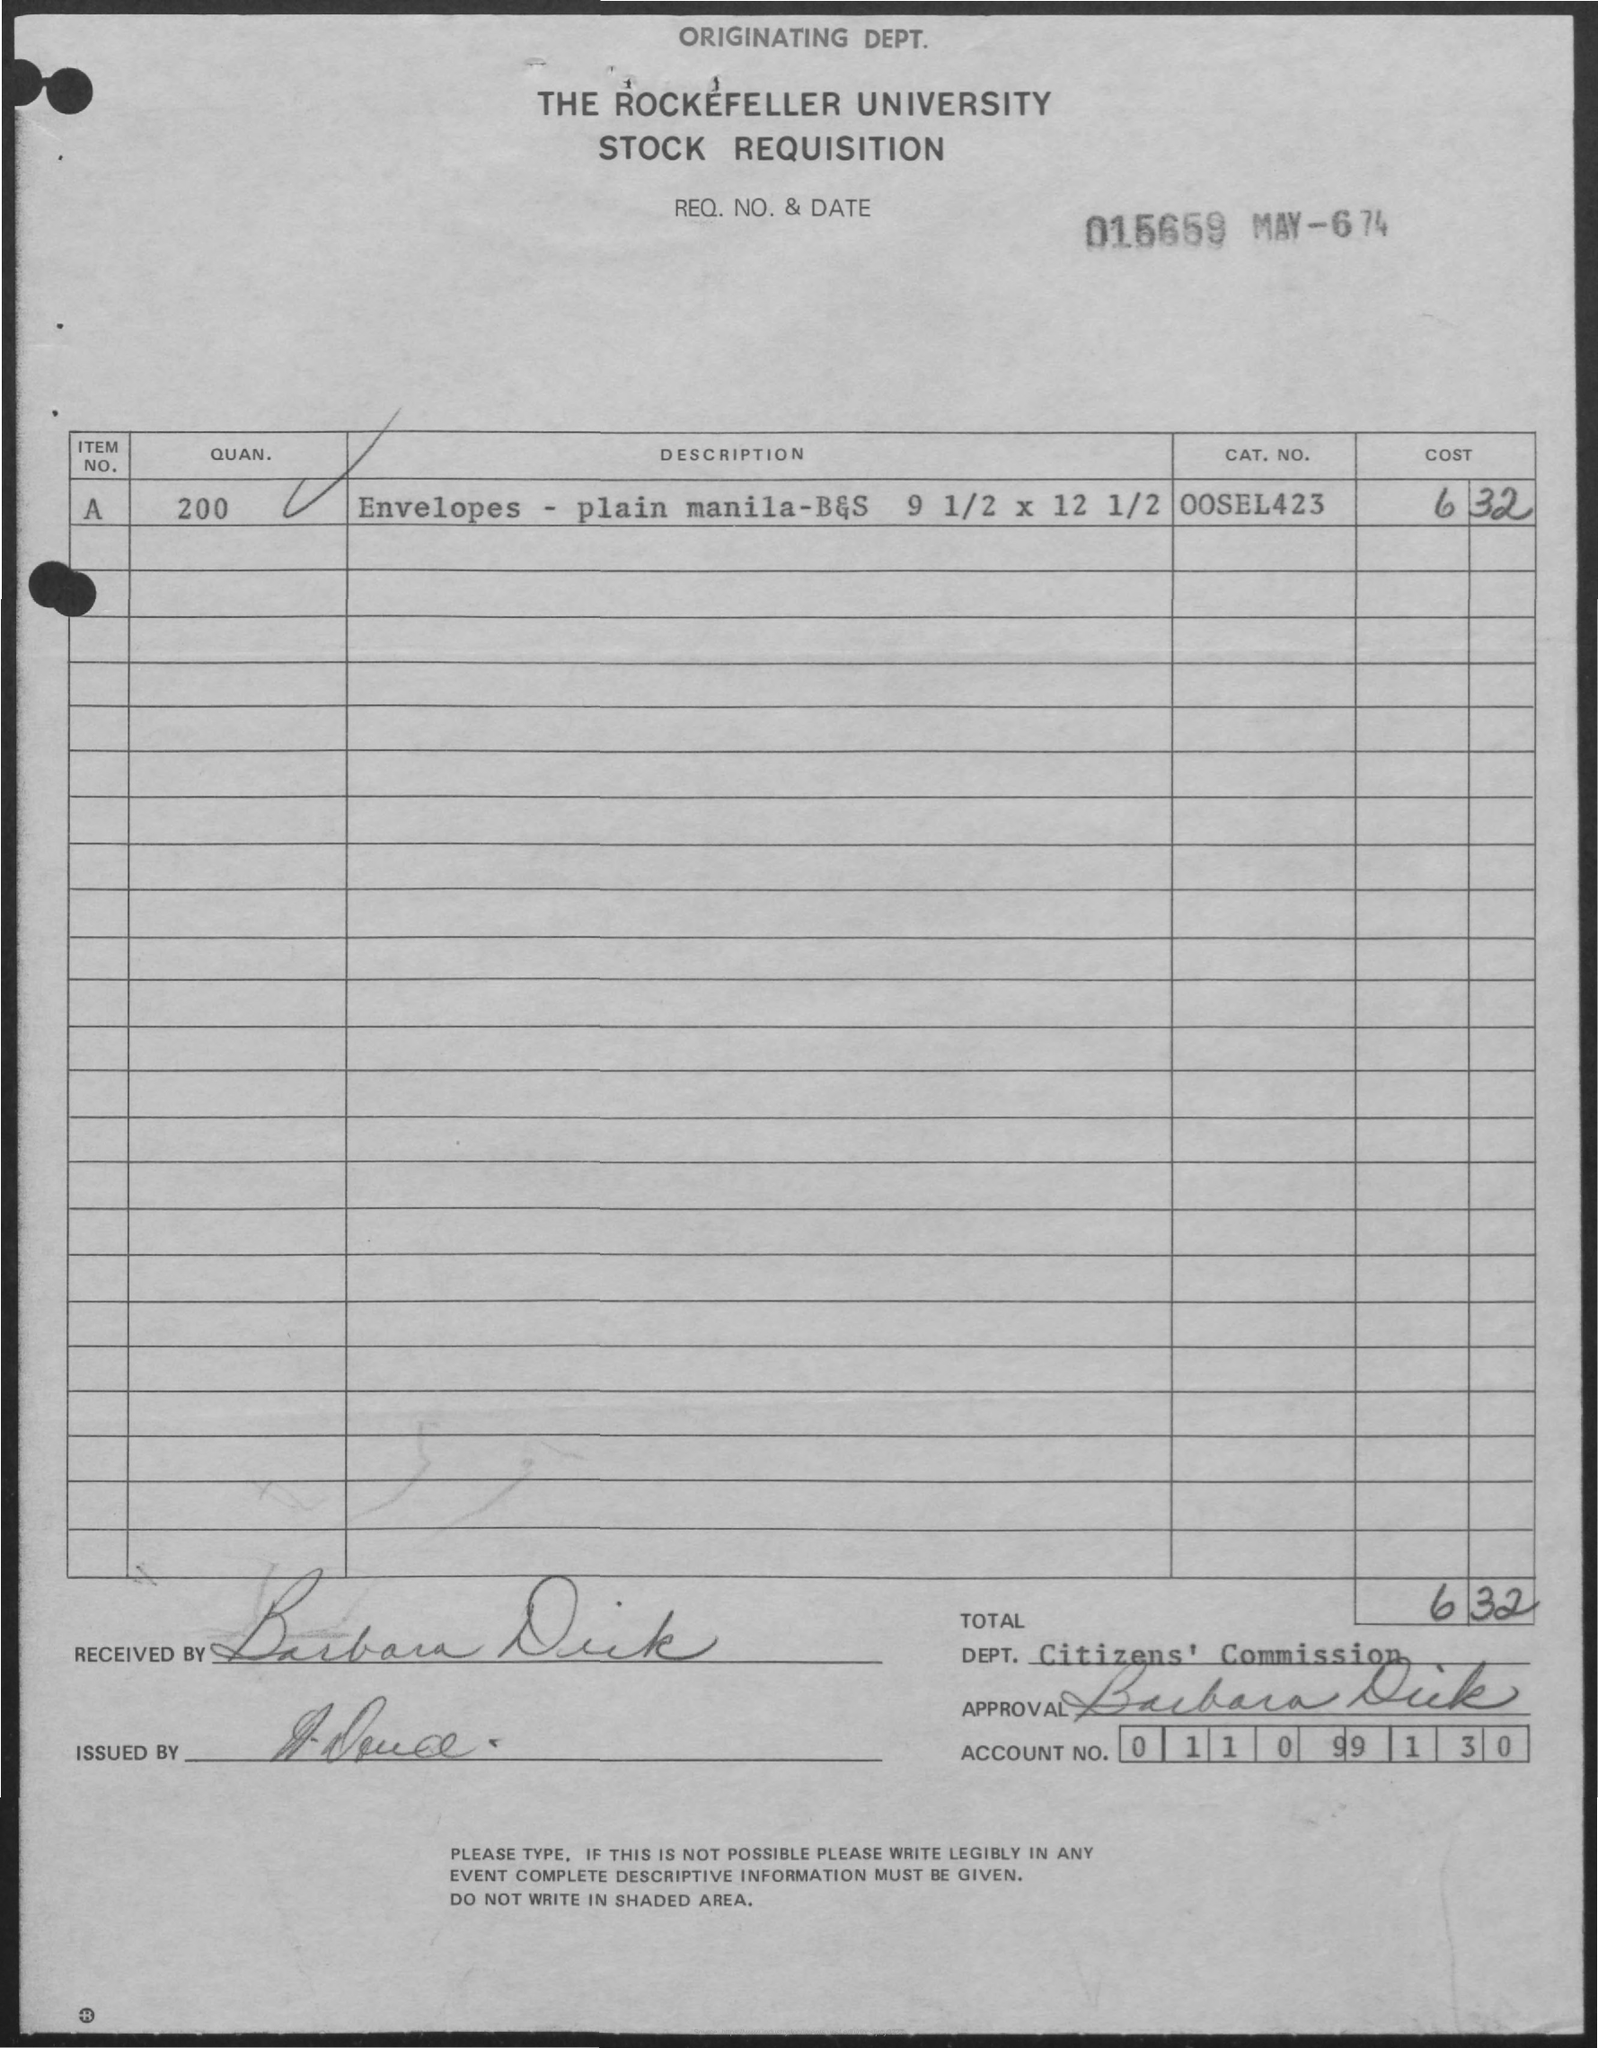What is the Quantity of item number A?
Make the answer very short. 200. What is the Category number of item number A?
Provide a succinct answer. 00sel423. What is the Account Number?
Give a very brief answer. 011099130. What is the date?
Offer a very short reply. May-6 74. What is the total cost?
Your answer should be compact. 6.32. What is the Department Name?
Your response must be concise. Citizens' commission. 